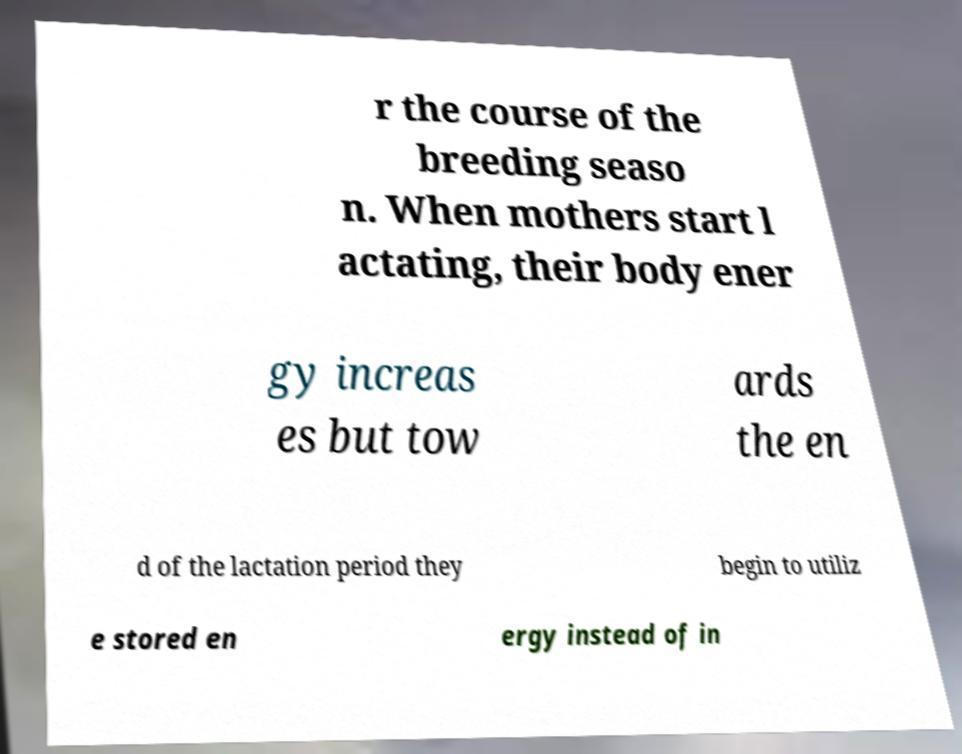What messages or text are displayed in this image? I need them in a readable, typed format. r the course of the breeding seaso n. When mothers start l actating, their body ener gy increas es but tow ards the en d of the lactation period they begin to utiliz e stored en ergy instead of in 